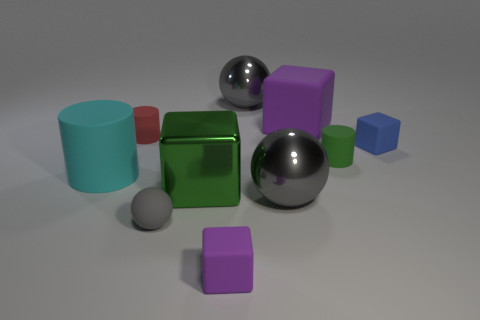Subtract all red cylinders. How many purple blocks are left? 2 Subtract all small matte balls. How many balls are left? 2 Subtract all green blocks. How many blocks are left? 3 Subtract 1 balls. How many balls are left? 2 Subtract all blocks. How many objects are left? 6 Subtract all purple balls. Subtract all cyan cylinders. How many balls are left? 3 Add 9 green metal objects. How many green metal objects are left? 10 Add 8 large purple things. How many large purple things exist? 9 Subtract 1 blue cubes. How many objects are left? 9 Subtract all green blocks. Subtract all gray rubber balls. How many objects are left? 8 